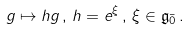Convert formula to latex. <formula><loc_0><loc_0><loc_500><loc_500>g \mapsto h g \, , \, h = e ^ { \xi } \, , \, \xi \in \mathfrak { g } _ { \bar { 0 } } \, .</formula> 